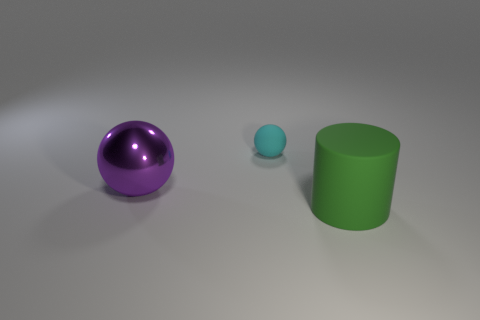Can you tell me the textures of the objects? The purple ball has a smooth, shiny surface suggestive of a polished material. The blue sphere also seems smooth but has a dull finish indicating less reflectiveness. The green cylinder features a matte texture, lacking any significant gloss or sheen. 